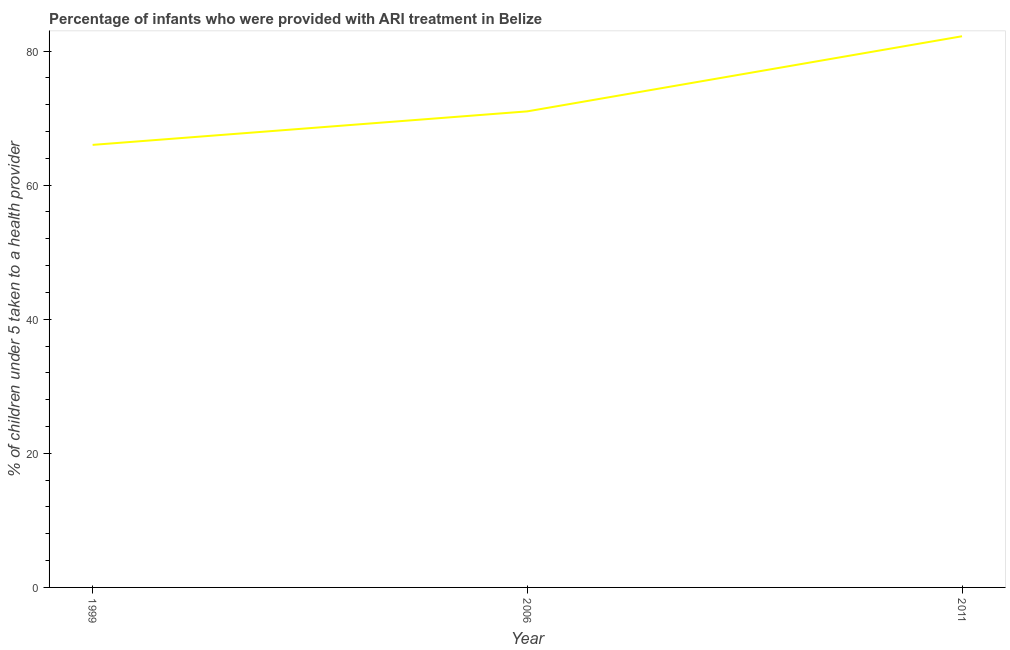What is the percentage of children who were provided with ari treatment in 1999?
Make the answer very short. 66. Across all years, what is the maximum percentage of children who were provided with ari treatment?
Your answer should be very brief. 82.2. In which year was the percentage of children who were provided with ari treatment minimum?
Your answer should be very brief. 1999. What is the sum of the percentage of children who were provided with ari treatment?
Ensure brevity in your answer.  219.2. What is the difference between the percentage of children who were provided with ari treatment in 1999 and 2011?
Offer a very short reply. -16.2. What is the average percentage of children who were provided with ari treatment per year?
Provide a succinct answer. 73.07. In how many years, is the percentage of children who were provided with ari treatment greater than 72 %?
Ensure brevity in your answer.  1. What is the ratio of the percentage of children who were provided with ari treatment in 2006 to that in 2011?
Offer a very short reply. 0.86. What is the difference between the highest and the second highest percentage of children who were provided with ari treatment?
Provide a short and direct response. 11.2. Is the sum of the percentage of children who were provided with ari treatment in 1999 and 2006 greater than the maximum percentage of children who were provided with ari treatment across all years?
Give a very brief answer. Yes. What is the difference between the highest and the lowest percentage of children who were provided with ari treatment?
Provide a short and direct response. 16.2. In how many years, is the percentage of children who were provided with ari treatment greater than the average percentage of children who were provided with ari treatment taken over all years?
Offer a very short reply. 1. Does the percentage of children who were provided with ari treatment monotonically increase over the years?
Keep it short and to the point. Yes. How many years are there in the graph?
Provide a succinct answer. 3. What is the difference between two consecutive major ticks on the Y-axis?
Make the answer very short. 20. Does the graph contain any zero values?
Make the answer very short. No. Does the graph contain grids?
Give a very brief answer. No. What is the title of the graph?
Keep it short and to the point. Percentage of infants who were provided with ARI treatment in Belize. What is the label or title of the Y-axis?
Offer a terse response. % of children under 5 taken to a health provider. What is the % of children under 5 taken to a health provider in 1999?
Provide a short and direct response. 66. What is the % of children under 5 taken to a health provider of 2006?
Provide a succinct answer. 71. What is the % of children under 5 taken to a health provider of 2011?
Your answer should be compact. 82.2. What is the difference between the % of children under 5 taken to a health provider in 1999 and 2011?
Make the answer very short. -16.2. What is the ratio of the % of children under 5 taken to a health provider in 1999 to that in 2006?
Offer a terse response. 0.93. What is the ratio of the % of children under 5 taken to a health provider in 1999 to that in 2011?
Provide a short and direct response. 0.8. What is the ratio of the % of children under 5 taken to a health provider in 2006 to that in 2011?
Provide a succinct answer. 0.86. 